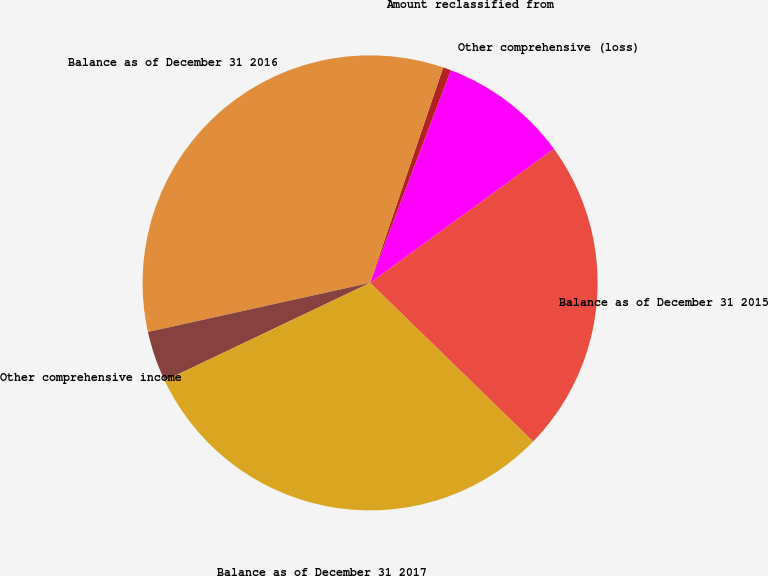Convert chart to OTSL. <chart><loc_0><loc_0><loc_500><loc_500><pie_chart><fcel>Balance as of December 31 2015<fcel>Other comprehensive (loss)<fcel>Amount reclassified from<fcel>Balance as of December 31 2016<fcel>Other comprehensive income<fcel>Balance as of December 31 2017<nl><fcel>22.32%<fcel>9.19%<fcel>0.57%<fcel>33.67%<fcel>3.61%<fcel>30.64%<nl></chart> 